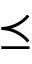Convert formula to latex. <formula><loc_0><loc_0><loc_500><loc_500>\preceq</formula> 